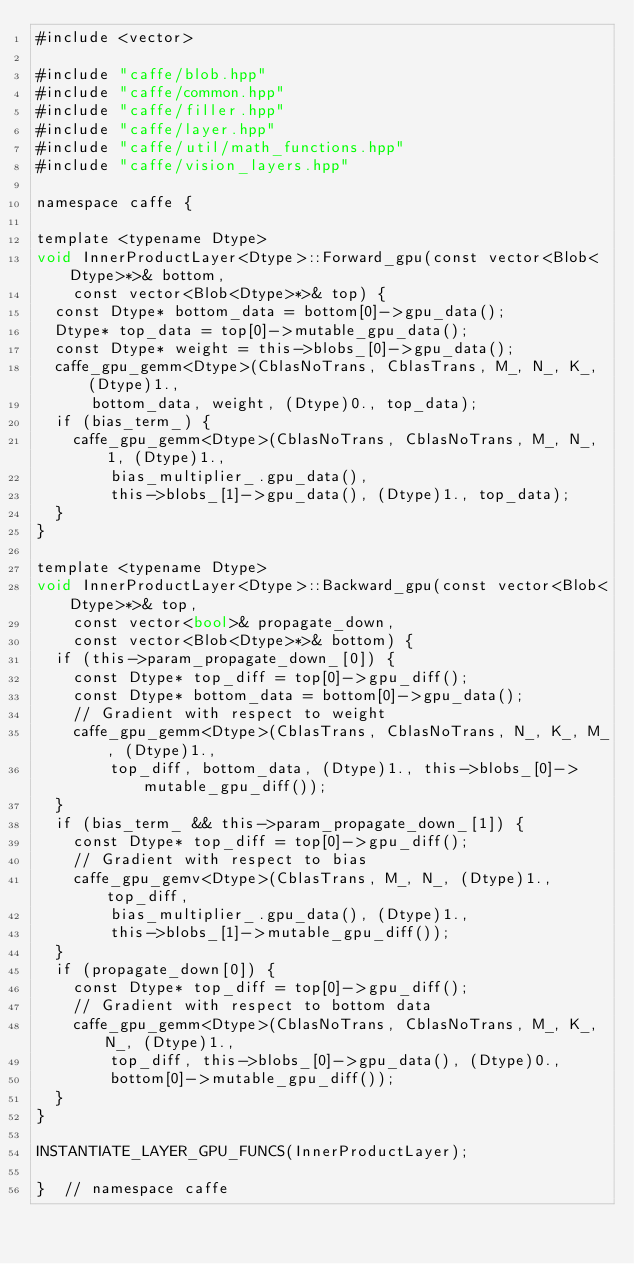<code> <loc_0><loc_0><loc_500><loc_500><_Cuda_>#include <vector>

#include "caffe/blob.hpp"
#include "caffe/common.hpp"
#include "caffe/filler.hpp"
#include "caffe/layer.hpp"
#include "caffe/util/math_functions.hpp"
#include "caffe/vision_layers.hpp"

namespace caffe {

template <typename Dtype>
void InnerProductLayer<Dtype>::Forward_gpu(const vector<Blob<Dtype>*>& bottom,
    const vector<Blob<Dtype>*>& top) {
  const Dtype* bottom_data = bottom[0]->gpu_data();
  Dtype* top_data = top[0]->mutable_gpu_data();
  const Dtype* weight = this->blobs_[0]->gpu_data();
  caffe_gpu_gemm<Dtype>(CblasNoTrans, CblasTrans, M_, N_, K_, (Dtype)1.,
      bottom_data, weight, (Dtype)0., top_data);
  if (bias_term_) {
    caffe_gpu_gemm<Dtype>(CblasNoTrans, CblasNoTrans, M_, N_, 1, (Dtype)1.,
        bias_multiplier_.gpu_data(),
        this->blobs_[1]->gpu_data(), (Dtype)1., top_data);
  }
}

template <typename Dtype>
void InnerProductLayer<Dtype>::Backward_gpu(const vector<Blob<Dtype>*>& top,
    const vector<bool>& propagate_down,
    const vector<Blob<Dtype>*>& bottom) {
  if (this->param_propagate_down_[0]) {
    const Dtype* top_diff = top[0]->gpu_diff();
    const Dtype* bottom_data = bottom[0]->gpu_data();
    // Gradient with respect to weight
    caffe_gpu_gemm<Dtype>(CblasTrans, CblasNoTrans, N_, K_, M_, (Dtype)1.,
        top_diff, bottom_data, (Dtype)1., this->blobs_[0]->mutable_gpu_diff());
  }
  if (bias_term_ && this->param_propagate_down_[1]) {
    const Dtype* top_diff = top[0]->gpu_diff();
    // Gradient with respect to bias
    caffe_gpu_gemv<Dtype>(CblasTrans, M_, N_, (Dtype)1., top_diff,
        bias_multiplier_.gpu_data(), (Dtype)1.,
        this->blobs_[1]->mutable_gpu_diff());
  }
  if (propagate_down[0]) {
    const Dtype* top_diff = top[0]->gpu_diff();
    // Gradient with respect to bottom data
    caffe_gpu_gemm<Dtype>(CblasNoTrans, CblasNoTrans, M_, K_, N_, (Dtype)1.,
        top_diff, this->blobs_[0]->gpu_data(), (Dtype)0.,
        bottom[0]->mutable_gpu_diff());
  }
}

INSTANTIATE_LAYER_GPU_FUNCS(InnerProductLayer);

}  // namespace caffe
</code> 